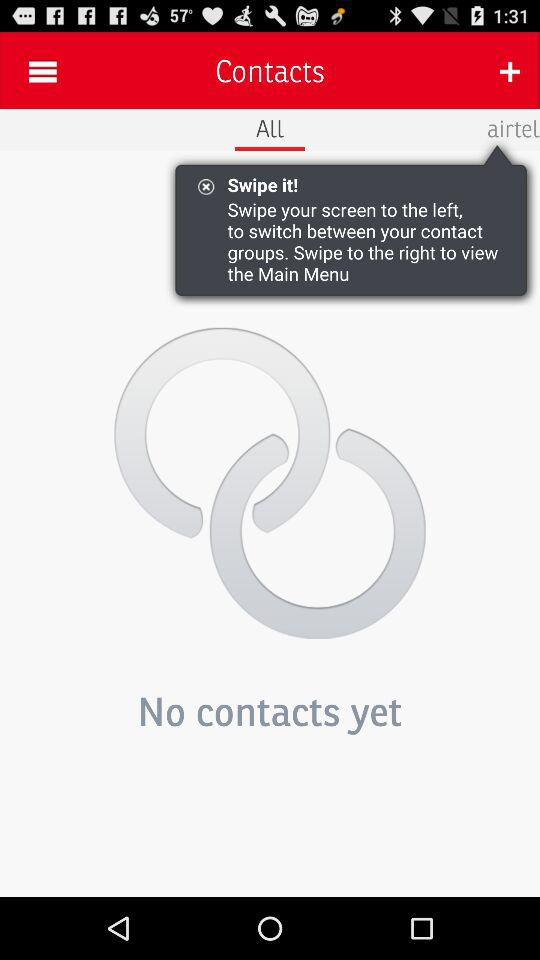How many contacts do I have?
Answer the question using a single word or phrase. 0 